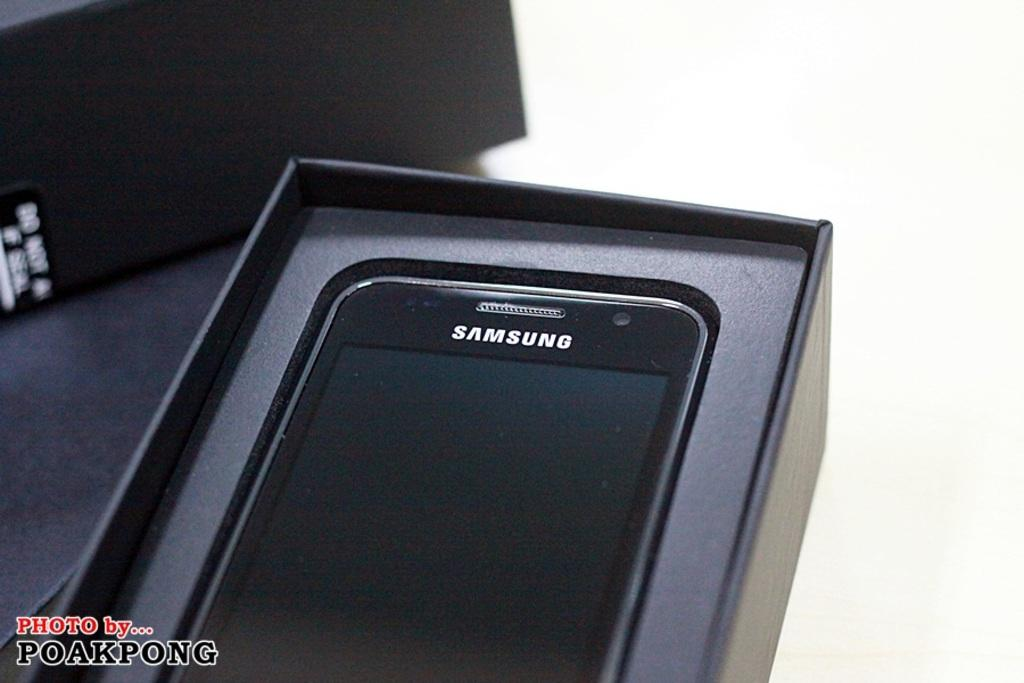<image>
Present a compact description of the photo's key features. A Samsung phone sits in its box on a table. 